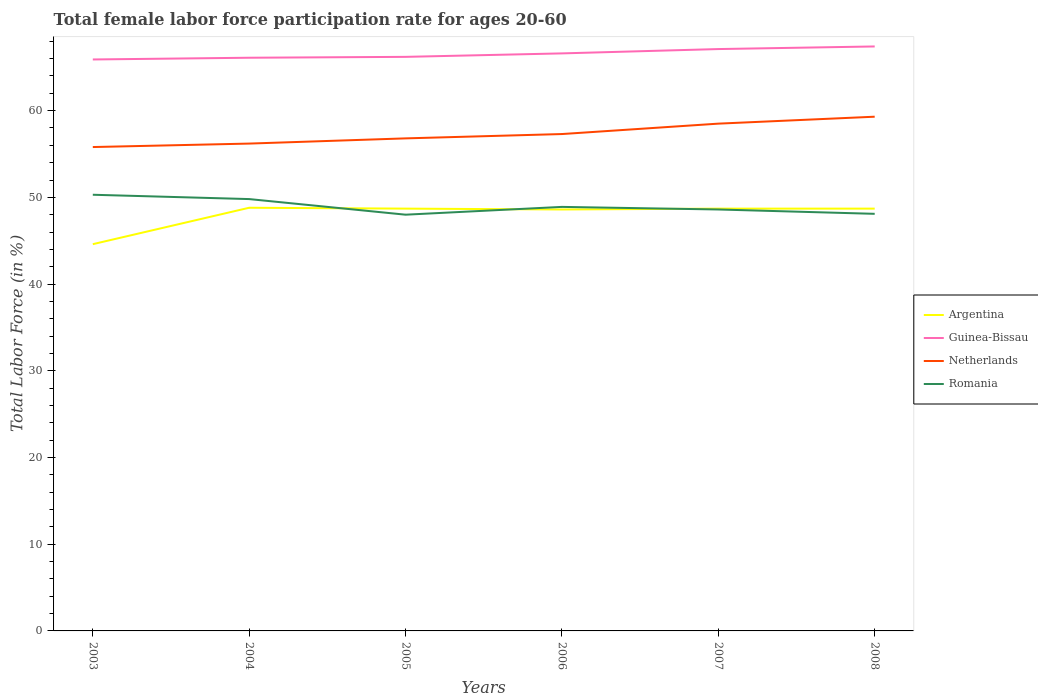Does the line corresponding to Argentina intersect with the line corresponding to Guinea-Bissau?
Offer a terse response. No. Across all years, what is the maximum female labor force participation rate in Argentina?
Ensure brevity in your answer.  44.6. In which year was the female labor force participation rate in Argentina maximum?
Provide a short and direct response. 2003. What is the total female labor force participation rate in Argentina in the graph?
Provide a short and direct response. 0.2. What is the difference between the highest and the second highest female labor force participation rate in Argentina?
Provide a short and direct response. 4.2. Is the female labor force participation rate in Argentina strictly greater than the female labor force participation rate in Netherlands over the years?
Your answer should be compact. Yes. How many lines are there?
Give a very brief answer. 4. How many years are there in the graph?
Give a very brief answer. 6. Are the values on the major ticks of Y-axis written in scientific E-notation?
Keep it short and to the point. No. Where does the legend appear in the graph?
Provide a succinct answer. Center right. How many legend labels are there?
Your answer should be very brief. 4. How are the legend labels stacked?
Give a very brief answer. Vertical. What is the title of the graph?
Make the answer very short. Total female labor force participation rate for ages 20-60. What is the label or title of the X-axis?
Provide a succinct answer. Years. What is the label or title of the Y-axis?
Your response must be concise. Total Labor Force (in %). What is the Total Labor Force (in %) of Argentina in 2003?
Your answer should be very brief. 44.6. What is the Total Labor Force (in %) in Guinea-Bissau in 2003?
Provide a succinct answer. 65.9. What is the Total Labor Force (in %) in Netherlands in 2003?
Ensure brevity in your answer.  55.8. What is the Total Labor Force (in %) of Romania in 2003?
Provide a short and direct response. 50.3. What is the Total Labor Force (in %) in Argentina in 2004?
Offer a terse response. 48.8. What is the Total Labor Force (in %) in Guinea-Bissau in 2004?
Offer a very short reply. 66.1. What is the Total Labor Force (in %) of Netherlands in 2004?
Make the answer very short. 56.2. What is the Total Labor Force (in %) in Romania in 2004?
Make the answer very short. 49.8. What is the Total Labor Force (in %) of Argentina in 2005?
Ensure brevity in your answer.  48.7. What is the Total Labor Force (in %) of Guinea-Bissau in 2005?
Offer a very short reply. 66.2. What is the Total Labor Force (in %) of Netherlands in 2005?
Provide a succinct answer. 56.8. What is the Total Labor Force (in %) in Romania in 2005?
Ensure brevity in your answer.  48. What is the Total Labor Force (in %) in Argentina in 2006?
Make the answer very short. 48.6. What is the Total Labor Force (in %) in Guinea-Bissau in 2006?
Keep it short and to the point. 66.6. What is the Total Labor Force (in %) in Netherlands in 2006?
Provide a short and direct response. 57.3. What is the Total Labor Force (in %) in Romania in 2006?
Your answer should be very brief. 48.9. What is the Total Labor Force (in %) of Argentina in 2007?
Offer a terse response. 48.7. What is the Total Labor Force (in %) in Guinea-Bissau in 2007?
Your answer should be compact. 67.1. What is the Total Labor Force (in %) in Netherlands in 2007?
Your answer should be very brief. 58.5. What is the Total Labor Force (in %) of Romania in 2007?
Make the answer very short. 48.6. What is the Total Labor Force (in %) in Argentina in 2008?
Your response must be concise. 48.7. What is the Total Labor Force (in %) of Guinea-Bissau in 2008?
Your answer should be compact. 67.4. What is the Total Labor Force (in %) of Netherlands in 2008?
Offer a very short reply. 59.3. What is the Total Labor Force (in %) of Romania in 2008?
Your answer should be compact. 48.1. Across all years, what is the maximum Total Labor Force (in %) in Argentina?
Offer a terse response. 48.8. Across all years, what is the maximum Total Labor Force (in %) of Guinea-Bissau?
Your response must be concise. 67.4. Across all years, what is the maximum Total Labor Force (in %) in Netherlands?
Your answer should be very brief. 59.3. Across all years, what is the maximum Total Labor Force (in %) in Romania?
Your response must be concise. 50.3. Across all years, what is the minimum Total Labor Force (in %) in Argentina?
Your answer should be very brief. 44.6. Across all years, what is the minimum Total Labor Force (in %) of Guinea-Bissau?
Ensure brevity in your answer.  65.9. Across all years, what is the minimum Total Labor Force (in %) in Netherlands?
Your answer should be very brief. 55.8. What is the total Total Labor Force (in %) in Argentina in the graph?
Provide a short and direct response. 288.1. What is the total Total Labor Force (in %) in Guinea-Bissau in the graph?
Give a very brief answer. 399.3. What is the total Total Labor Force (in %) of Netherlands in the graph?
Provide a short and direct response. 343.9. What is the total Total Labor Force (in %) of Romania in the graph?
Ensure brevity in your answer.  293.7. What is the difference between the Total Labor Force (in %) in Argentina in 2003 and that in 2004?
Provide a short and direct response. -4.2. What is the difference between the Total Labor Force (in %) in Guinea-Bissau in 2003 and that in 2004?
Your response must be concise. -0.2. What is the difference between the Total Labor Force (in %) in Guinea-Bissau in 2003 and that in 2005?
Ensure brevity in your answer.  -0.3. What is the difference between the Total Labor Force (in %) of Netherlands in 2003 and that in 2005?
Offer a terse response. -1. What is the difference between the Total Labor Force (in %) in Argentina in 2003 and that in 2006?
Ensure brevity in your answer.  -4. What is the difference between the Total Labor Force (in %) in Romania in 2003 and that in 2006?
Ensure brevity in your answer.  1.4. What is the difference between the Total Labor Force (in %) of Guinea-Bissau in 2003 and that in 2007?
Your answer should be compact. -1.2. What is the difference between the Total Labor Force (in %) in Romania in 2003 and that in 2007?
Offer a very short reply. 1.7. What is the difference between the Total Labor Force (in %) of Argentina in 2003 and that in 2008?
Your response must be concise. -4.1. What is the difference between the Total Labor Force (in %) in Netherlands in 2003 and that in 2008?
Provide a succinct answer. -3.5. What is the difference between the Total Labor Force (in %) in Romania in 2003 and that in 2008?
Your answer should be compact. 2.2. What is the difference between the Total Labor Force (in %) in Argentina in 2004 and that in 2005?
Your answer should be compact. 0.1. What is the difference between the Total Labor Force (in %) of Netherlands in 2004 and that in 2005?
Your response must be concise. -0.6. What is the difference between the Total Labor Force (in %) of Netherlands in 2004 and that in 2006?
Offer a terse response. -1.1. What is the difference between the Total Labor Force (in %) in Romania in 2004 and that in 2006?
Offer a very short reply. 0.9. What is the difference between the Total Labor Force (in %) of Argentina in 2004 and that in 2007?
Ensure brevity in your answer.  0.1. What is the difference between the Total Labor Force (in %) of Guinea-Bissau in 2004 and that in 2007?
Keep it short and to the point. -1. What is the difference between the Total Labor Force (in %) in Argentina in 2004 and that in 2008?
Provide a succinct answer. 0.1. What is the difference between the Total Labor Force (in %) of Guinea-Bissau in 2004 and that in 2008?
Offer a very short reply. -1.3. What is the difference between the Total Labor Force (in %) in Netherlands in 2004 and that in 2008?
Offer a very short reply. -3.1. What is the difference between the Total Labor Force (in %) of Argentina in 2005 and that in 2006?
Offer a very short reply. 0.1. What is the difference between the Total Labor Force (in %) in Netherlands in 2005 and that in 2006?
Make the answer very short. -0.5. What is the difference between the Total Labor Force (in %) in Romania in 2005 and that in 2007?
Give a very brief answer. -0.6. What is the difference between the Total Labor Force (in %) in Argentina in 2005 and that in 2008?
Offer a terse response. 0. What is the difference between the Total Labor Force (in %) of Guinea-Bissau in 2005 and that in 2008?
Your response must be concise. -1.2. What is the difference between the Total Labor Force (in %) in Netherlands in 2005 and that in 2008?
Provide a short and direct response. -2.5. What is the difference between the Total Labor Force (in %) of Netherlands in 2006 and that in 2007?
Your answer should be compact. -1.2. What is the difference between the Total Labor Force (in %) of Romania in 2006 and that in 2007?
Your answer should be compact. 0.3. What is the difference between the Total Labor Force (in %) of Guinea-Bissau in 2006 and that in 2008?
Offer a terse response. -0.8. What is the difference between the Total Labor Force (in %) in Netherlands in 2006 and that in 2008?
Offer a very short reply. -2. What is the difference between the Total Labor Force (in %) in Romania in 2007 and that in 2008?
Ensure brevity in your answer.  0.5. What is the difference between the Total Labor Force (in %) in Argentina in 2003 and the Total Labor Force (in %) in Guinea-Bissau in 2004?
Your answer should be compact. -21.5. What is the difference between the Total Labor Force (in %) in Argentina in 2003 and the Total Labor Force (in %) in Netherlands in 2004?
Offer a terse response. -11.6. What is the difference between the Total Labor Force (in %) of Argentina in 2003 and the Total Labor Force (in %) of Romania in 2004?
Your answer should be compact. -5.2. What is the difference between the Total Labor Force (in %) in Guinea-Bissau in 2003 and the Total Labor Force (in %) in Netherlands in 2004?
Your answer should be compact. 9.7. What is the difference between the Total Labor Force (in %) in Guinea-Bissau in 2003 and the Total Labor Force (in %) in Romania in 2004?
Make the answer very short. 16.1. What is the difference between the Total Labor Force (in %) in Netherlands in 2003 and the Total Labor Force (in %) in Romania in 2004?
Provide a short and direct response. 6. What is the difference between the Total Labor Force (in %) in Argentina in 2003 and the Total Labor Force (in %) in Guinea-Bissau in 2005?
Keep it short and to the point. -21.6. What is the difference between the Total Labor Force (in %) of Argentina in 2003 and the Total Labor Force (in %) of Netherlands in 2005?
Make the answer very short. -12.2. What is the difference between the Total Labor Force (in %) in Argentina in 2003 and the Total Labor Force (in %) in Romania in 2005?
Provide a succinct answer. -3.4. What is the difference between the Total Labor Force (in %) in Guinea-Bissau in 2003 and the Total Labor Force (in %) in Netherlands in 2005?
Keep it short and to the point. 9.1. What is the difference between the Total Labor Force (in %) of Guinea-Bissau in 2003 and the Total Labor Force (in %) of Romania in 2005?
Your answer should be compact. 17.9. What is the difference between the Total Labor Force (in %) of Argentina in 2003 and the Total Labor Force (in %) of Guinea-Bissau in 2006?
Your answer should be compact. -22. What is the difference between the Total Labor Force (in %) of Argentina in 2003 and the Total Labor Force (in %) of Guinea-Bissau in 2007?
Keep it short and to the point. -22.5. What is the difference between the Total Labor Force (in %) of Argentina in 2003 and the Total Labor Force (in %) of Romania in 2007?
Offer a very short reply. -4. What is the difference between the Total Labor Force (in %) of Guinea-Bissau in 2003 and the Total Labor Force (in %) of Netherlands in 2007?
Offer a terse response. 7.4. What is the difference between the Total Labor Force (in %) in Guinea-Bissau in 2003 and the Total Labor Force (in %) in Romania in 2007?
Keep it short and to the point. 17.3. What is the difference between the Total Labor Force (in %) in Netherlands in 2003 and the Total Labor Force (in %) in Romania in 2007?
Provide a short and direct response. 7.2. What is the difference between the Total Labor Force (in %) of Argentina in 2003 and the Total Labor Force (in %) of Guinea-Bissau in 2008?
Ensure brevity in your answer.  -22.8. What is the difference between the Total Labor Force (in %) in Argentina in 2003 and the Total Labor Force (in %) in Netherlands in 2008?
Ensure brevity in your answer.  -14.7. What is the difference between the Total Labor Force (in %) in Argentina in 2003 and the Total Labor Force (in %) in Romania in 2008?
Offer a very short reply. -3.5. What is the difference between the Total Labor Force (in %) of Guinea-Bissau in 2003 and the Total Labor Force (in %) of Romania in 2008?
Ensure brevity in your answer.  17.8. What is the difference between the Total Labor Force (in %) in Argentina in 2004 and the Total Labor Force (in %) in Guinea-Bissau in 2005?
Provide a succinct answer. -17.4. What is the difference between the Total Labor Force (in %) of Argentina in 2004 and the Total Labor Force (in %) of Romania in 2005?
Your response must be concise. 0.8. What is the difference between the Total Labor Force (in %) of Guinea-Bissau in 2004 and the Total Labor Force (in %) of Netherlands in 2005?
Your response must be concise. 9.3. What is the difference between the Total Labor Force (in %) in Guinea-Bissau in 2004 and the Total Labor Force (in %) in Romania in 2005?
Offer a very short reply. 18.1. What is the difference between the Total Labor Force (in %) in Netherlands in 2004 and the Total Labor Force (in %) in Romania in 2005?
Offer a very short reply. 8.2. What is the difference between the Total Labor Force (in %) in Argentina in 2004 and the Total Labor Force (in %) in Guinea-Bissau in 2006?
Your response must be concise. -17.8. What is the difference between the Total Labor Force (in %) of Argentina in 2004 and the Total Labor Force (in %) of Netherlands in 2006?
Your answer should be compact. -8.5. What is the difference between the Total Labor Force (in %) in Argentina in 2004 and the Total Labor Force (in %) in Romania in 2006?
Offer a terse response. -0.1. What is the difference between the Total Labor Force (in %) in Guinea-Bissau in 2004 and the Total Labor Force (in %) in Netherlands in 2006?
Your answer should be very brief. 8.8. What is the difference between the Total Labor Force (in %) of Argentina in 2004 and the Total Labor Force (in %) of Guinea-Bissau in 2007?
Provide a succinct answer. -18.3. What is the difference between the Total Labor Force (in %) of Guinea-Bissau in 2004 and the Total Labor Force (in %) of Netherlands in 2007?
Ensure brevity in your answer.  7.6. What is the difference between the Total Labor Force (in %) in Netherlands in 2004 and the Total Labor Force (in %) in Romania in 2007?
Provide a succinct answer. 7.6. What is the difference between the Total Labor Force (in %) in Argentina in 2004 and the Total Labor Force (in %) in Guinea-Bissau in 2008?
Offer a very short reply. -18.6. What is the difference between the Total Labor Force (in %) in Argentina in 2004 and the Total Labor Force (in %) in Netherlands in 2008?
Provide a short and direct response. -10.5. What is the difference between the Total Labor Force (in %) of Guinea-Bissau in 2004 and the Total Labor Force (in %) of Netherlands in 2008?
Ensure brevity in your answer.  6.8. What is the difference between the Total Labor Force (in %) in Guinea-Bissau in 2004 and the Total Labor Force (in %) in Romania in 2008?
Provide a succinct answer. 18. What is the difference between the Total Labor Force (in %) of Netherlands in 2004 and the Total Labor Force (in %) of Romania in 2008?
Provide a short and direct response. 8.1. What is the difference between the Total Labor Force (in %) in Argentina in 2005 and the Total Labor Force (in %) in Guinea-Bissau in 2006?
Your answer should be compact. -17.9. What is the difference between the Total Labor Force (in %) in Argentina in 2005 and the Total Labor Force (in %) in Netherlands in 2006?
Offer a terse response. -8.6. What is the difference between the Total Labor Force (in %) in Argentina in 2005 and the Total Labor Force (in %) in Guinea-Bissau in 2007?
Give a very brief answer. -18.4. What is the difference between the Total Labor Force (in %) of Argentina in 2005 and the Total Labor Force (in %) of Romania in 2007?
Your answer should be very brief. 0.1. What is the difference between the Total Labor Force (in %) in Guinea-Bissau in 2005 and the Total Labor Force (in %) in Netherlands in 2007?
Your answer should be very brief. 7.7. What is the difference between the Total Labor Force (in %) in Argentina in 2005 and the Total Labor Force (in %) in Guinea-Bissau in 2008?
Provide a succinct answer. -18.7. What is the difference between the Total Labor Force (in %) of Argentina in 2005 and the Total Labor Force (in %) of Romania in 2008?
Provide a short and direct response. 0.6. What is the difference between the Total Labor Force (in %) of Guinea-Bissau in 2005 and the Total Labor Force (in %) of Netherlands in 2008?
Your answer should be compact. 6.9. What is the difference between the Total Labor Force (in %) in Netherlands in 2005 and the Total Labor Force (in %) in Romania in 2008?
Give a very brief answer. 8.7. What is the difference between the Total Labor Force (in %) of Argentina in 2006 and the Total Labor Force (in %) of Guinea-Bissau in 2007?
Offer a very short reply. -18.5. What is the difference between the Total Labor Force (in %) in Argentina in 2006 and the Total Labor Force (in %) in Netherlands in 2007?
Your answer should be very brief. -9.9. What is the difference between the Total Labor Force (in %) of Guinea-Bissau in 2006 and the Total Labor Force (in %) of Netherlands in 2007?
Give a very brief answer. 8.1. What is the difference between the Total Labor Force (in %) of Guinea-Bissau in 2006 and the Total Labor Force (in %) of Romania in 2007?
Offer a terse response. 18. What is the difference between the Total Labor Force (in %) of Netherlands in 2006 and the Total Labor Force (in %) of Romania in 2007?
Give a very brief answer. 8.7. What is the difference between the Total Labor Force (in %) of Argentina in 2006 and the Total Labor Force (in %) of Guinea-Bissau in 2008?
Your response must be concise. -18.8. What is the difference between the Total Labor Force (in %) in Argentina in 2006 and the Total Labor Force (in %) in Romania in 2008?
Your response must be concise. 0.5. What is the difference between the Total Labor Force (in %) in Netherlands in 2006 and the Total Labor Force (in %) in Romania in 2008?
Your answer should be compact. 9.2. What is the difference between the Total Labor Force (in %) in Argentina in 2007 and the Total Labor Force (in %) in Guinea-Bissau in 2008?
Your answer should be compact. -18.7. What is the difference between the Total Labor Force (in %) in Argentina in 2007 and the Total Labor Force (in %) in Romania in 2008?
Offer a very short reply. 0.6. What is the difference between the Total Labor Force (in %) of Guinea-Bissau in 2007 and the Total Labor Force (in %) of Netherlands in 2008?
Offer a very short reply. 7.8. What is the difference between the Total Labor Force (in %) in Netherlands in 2007 and the Total Labor Force (in %) in Romania in 2008?
Ensure brevity in your answer.  10.4. What is the average Total Labor Force (in %) in Argentina per year?
Provide a short and direct response. 48.02. What is the average Total Labor Force (in %) in Guinea-Bissau per year?
Your response must be concise. 66.55. What is the average Total Labor Force (in %) in Netherlands per year?
Keep it short and to the point. 57.32. What is the average Total Labor Force (in %) in Romania per year?
Make the answer very short. 48.95. In the year 2003, what is the difference between the Total Labor Force (in %) of Argentina and Total Labor Force (in %) of Guinea-Bissau?
Make the answer very short. -21.3. In the year 2003, what is the difference between the Total Labor Force (in %) in Argentina and Total Labor Force (in %) in Romania?
Provide a succinct answer. -5.7. In the year 2003, what is the difference between the Total Labor Force (in %) of Guinea-Bissau and Total Labor Force (in %) of Netherlands?
Make the answer very short. 10.1. In the year 2003, what is the difference between the Total Labor Force (in %) in Guinea-Bissau and Total Labor Force (in %) in Romania?
Ensure brevity in your answer.  15.6. In the year 2004, what is the difference between the Total Labor Force (in %) in Argentina and Total Labor Force (in %) in Guinea-Bissau?
Ensure brevity in your answer.  -17.3. In the year 2004, what is the difference between the Total Labor Force (in %) of Argentina and Total Labor Force (in %) of Romania?
Offer a very short reply. -1. In the year 2004, what is the difference between the Total Labor Force (in %) of Guinea-Bissau and Total Labor Force (in %) of Netherlands?
Offer a very short reply. 9.9. In the year 2004, what is the difference between the Total Labor Force (in %) in Netherlands and Total Labor Force (in %) in Romania?
Make the answer very short. 6.4. In the year 2005, what is the difference between the Total Labor Force (in %) in Argentina and Total Labor Force (in %) in Guinea-Bissau?
Your answer should be very brief. -17.5. In the year 2005, what is the difference between the Total Labor Force (in %) of Argentina and Total Labor Force (in %) of Netherlands?
Make the answer very short. -8.1. In the year 2005, what is the difference between the Total Labor Force (in %) of Argentina and Total Labor Force (in %) of Romania?
Ensure brevity in your answer.  0.7. In the year 2005, what is the difference between the Total Labor Force (in %) in Guinea-Bissau and Total Labor Force (in %) in Netherlands?
Your answer should be very brief. 9.4. In the year 2005, what is the difference between the Total Labor Force (in %) of Guinea-Bissau and Total Labor Force (in %) of Romania?
Ensure brevity in your answer.  18.2. In the year 2005, what is the difference between the Total Labor Force (in %) of Netherlands and Total Labor Force (in %) of Romania?
Ensure brevity in your answer.  8.8. In the year 2006, what is the difference between the Total Labor Force (in %) of Guinea-Bissau and Total Labor Force (in %) of Netherlands?
Provide a short and direct response. 9.3. In the year 2007, what is the difference between the Total Labor Force (in %) of Argentina and Total Labor Force (in %) of Guinea-Bissau?
Offer a very short reply. -18.4. In the year 2007, what is the difference between the Total Labor Force (in %) in Argentina and Total Labor Force (in %) in Netherlands?
Provide a succinct answer. -9.8. In the year 2007, what is the difference between the Total Labor Force (in %) in Netherlands and Total Labor Force (in %) in Romania?
Ensure brevity in your answer.  9.9. In the year 2008, what is the difference between the Total Labor Force (in %) in Argentina and Total Labor Force (in %) in Guinea-Bissau?
Provide a succinct answer. -18.7. In the year 2008, what is the difference between the Total Labor Force (in %) in Argentina and Total Labor Force (in %) in Netherlands?
Keep it short and to the point. -10.6. In the year 2008, what is the difference between the Total Labor Force (in %) of Argentina and Total Labor Force (in %) of Romania?
Your answer should be compact. 0.6. In the year 2008, what is the difference between the Total Labor Force (in %) in Guinea-Bissau and Total Labor Force (in %) in Netherlands?
Ensure brevity in your answer.  8.1. In the year 2008, what is the difference between the Total Labor Force (in %) of Guinea-Bissau and Total Labor Force (in %) of Romania?
Your response must be concise. 19.3. In the year 2008, what is the difference between the Total Labor Force (in %) of Netherlands and Total Labor Force (in %) of Romania?
Your answer should be compact. 11.2. What is the ratio of the Total Labor Force (in %) in Argentina in 2003 to that in 2004?
Provide a short and direct response. 0.91. What is the ratio of the Total Labor Force (in %) in Romania in 2003 to that in 2004?
Your response must be concise. 1.01. What is the ratio of the Total Labor Force (in %) of Argentina in 2003 to that in 2005?
Your answer should be very brief. 0.92. What is the ratio of the Total Labor Force (in %) of Netherlands in 2003 to that in 2005?
Make the answer very short. 0.98. What is the ratio of the Total Labor Force (in %) in Romania in 2003 to that in 2005?
Provide a short and direct response. 1.05. What is the ratio of the Total Labor Force (in %) of Argentina in 2003 to that in 2006?
Your answer should be compact. 0.92. What is the ratio of the Total Labor Force (in %) in Guinea-Bissau in 2003 to that in 2006?
Keep it short and to the point. 0.99. What is the ratio of the Total Labor Force (in %) in Netherlands in 2003 to that in 2006?
Ensure brevity in your answer.  0.97. What is the ratio of the Total Labor Force (in %) of Romania in 2003 to that in 2006?
Ensure brevity in your answer.  1.03. What is the ratio of the Total Labor Force (in %) of Argentina in 2003 to that in 2007?
Ensure brevity in your answer.  0.92. What is the ratio of the Total Labor Force (in %) in Guinea-Bissau in 2003 to that in 2007?
Keep it short and to the point. 0.98. What is the ratio of the Total Labor Force (in %) in Netherlands in 2003 to that in 2007?
Your answer should be compact. 0.95. What is the ratio of the Total Labor Force (in %) of Romania in 2003 to that in 2007?
Ensure brevity in your answer.  1.03. What is the ratio of the Total Labor Force (in %) of Argentina in 2003 to that in 2008?
Your answer should be compact. 0.92. What is the ratio of the Total Labor Force (in %) of Guinea-Bissau in 2003 to that in 2008?
Provide a short and direct response. 0.98. What is the ratio of the Total Labor Force (in %) in Netherlands in 2003 to that in 2008?
Offer a terse response. 0.94. What is the ratio of the Total Labor Force (in %) of Romania in 2003 to that in 2008?
Keep it short and to the point. 1.05. What is the ratio of the Total Labor Force (in %) in Netherlands in 2004 to that in 2005?
Provide a succinct answer. 0.99. What is the ratio of the Total Labor Force (in %) in Romania in 2004 to that in 2005?
Keep it short and to the point. 1.04. What is the ratio of the Total Labor Force (in %) of Guinea-Bissau in 2004 to that in 2006?
Give a very brief answer. 0.99. What is the ratio of the Total Labor Force (in %) in Netherlands in 2004 to that in 2006?
Give a very brief answer. 0.98. What is the ratio of the Total Labor Force (in %) in Romania in 2004 to that in 2006?
Offer a terse response. 1.02. What is the ratio of the Total Labor Force (in %) of Argentina in 2004 to that in 2007?
Provide a succinct answer. 1. What is the ratio of the Total Labor Force (in %) in Guinea-Bissau in 2004 to that in 2007?
Ensure brevity in your answer.  0.99. What is the ratio of the Total Labor Force (in %) in Netherlands in 2004 to that in 2007?
Make the answer very short. 0.96. What is the ratio of the Total Labor Force (in %) in Romania in 2004 to that in 2007?
Ensure brevity in your answer.  1.02. What is the ratio of the Total Labor Force (in %) in Guinea-Bissau in 2004 to that in 2008?
Your answer should be compact. 0.98. What is the ratio of the Total Labor Force (in %) of Netherlands in 2004 to that in 2008?
Give a very brief answer. 0.95. What is the ratio of the Total Labor Force (in %) in Romania in 2004 to that in 2008?
Your response must be concise. 1.04. What is the ratio of the Total Labor Force (in %) in Romania in 2005 to that in 2006?
Provide a short and direct response. 0.98. What is the ratio of the Total Labor Force (in %) in Argentina in 2005 to that in 2007?
Your response must be concise. 1. What is the ratio of the Total Labor Force (in %) in Guinea-Bissau in 2005 to that in 2007?
Make the answer very short. 0.99. What is the ratio of the Total Labor Force (in %) in Netherlands in 2005 to that in 2007?
Your response must be concise. 0.97. What is the ratio of the Total Labor Force (in %) of Romania in 2005 to that in 2007?
Make the answer very short. 0.99. What is the ratio of the Total Labor Force (in %) of Argentina in 2005 to that in 2008?
Your answer should be very brief. 1. What is the ratio of the Total Labor Force (in %) in Guinea-Bissau in 2005 to that in 2008?
Your answer should be compact. 0.98. What is the ratio of the Total Labor Force (in %) of Netherlands in 2005 to that in 2008?
Make the answer very short. 0.96. What is the ratio of the Total Labor Force (in %) in Romania in 2005 to that in 2008?
Offer a very short reply. 1. What is the ratio of the Total Labor Force (in %) of Argentina in 2006 to that in 2007?
Make the answer very short. 1. What is the ratio of the Total Labor Force (in %) in Guinea-Bissau in 2006 to that in 2007?
Offer a terse response. 0.99. What is the ratio of the Total Labor Force (in %) in Netherlands in 2006 to that in 2007?
Provide a short and direct response. 0.98. What is the ratio of the Total Labor Force (in %) in Argentina in 2006 to that in 2008?
Your answer should be very brief. 1. What is the ratio of the Total Labor Force (in %) of Netherlands in 2006 to that in 2008?
Your response must be concise. 0.97. What is the ratio of the Total Labor Force (in %) in Romania in 2006 to that in 2008?
Make the answer very short. 1.02. What is the ratio of the Total Labor Force (in %) of Guinea-Bissau in 2007 to that in 2008?
Your answer should be very brief. 1. What is the ratio of the Total Labor Force (in %) in Netherlands in 2007 to that in 2008?
Offer a very short reply. 0.99. What is the ratio of the Total Labor Force (in %) of Romania in 2007 to that in 2008?
Your answer should be compact. 1.01. What is the difference between the highest and the second highest Total Labor Force (in %) in Argentina?
Give a very brief answer. 0.1. What is the difference between the highest and the second highest Total Labor Force (in %) of Guinea-Bissau?
Ensure brevity in your answer.  0.3. What is the difference between the highest and the second highest Total Labor Force (in %) of Netherlands?
Provide a succinct answer. 0.8. What is the difference between the highest and the second highest Total Labor Force (in %) in Romania?
Keep it short and to the point. 0.5. What is the difference between the highest and the lowest Total Labor Force (in %) of Argentina?
Make the answer very short. 4.2. What is the difference between the highest and the lowest Total Labor Force (in %) in Netherlands?
Make the answer very short. 3.5. What is the difference between the highest and the lowest Total Labor Force (in %) of Romania?
Ensure brevity in your answer.  2.3. 